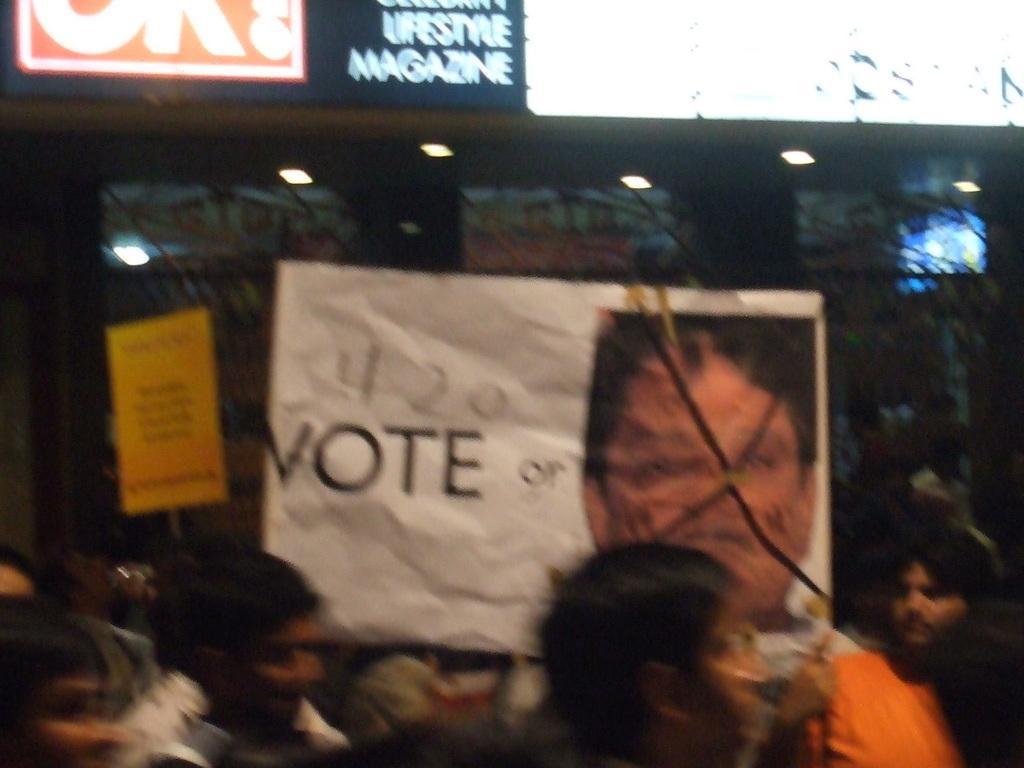Can you describe this image briefly? In this picture, we can see a few people, and a few are holding posters with some text, and images on it, we can see posters with lights, and we can see a few lights. 